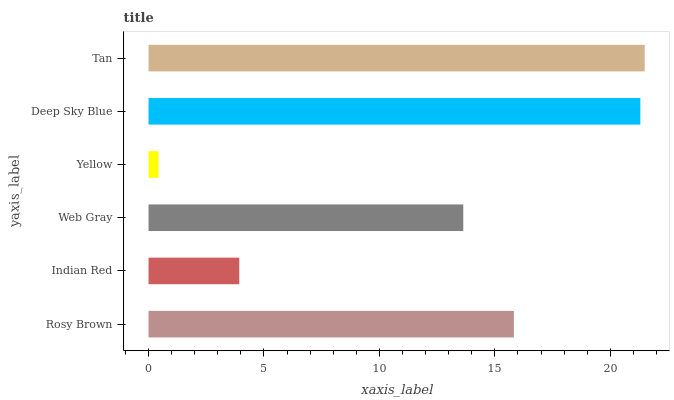Is Yellow the minimum?
Answer yes or no. Yes. Is Tan the maximum?
Answer yes or no. Yes. Is Indian Red the minimum?
Answer yes or no. No. Is Indian Red the maximum?
Answer yes or no. No. Is Rosy Brown greater than Indian Red?
Answer yes or no. Yes. Is Indian Red less than Rosy Brown?
Answer yes or no. Yes. Is Indian Red greater than Rosy Brown?
Answer yes or no. No. Is Rosy Brown less than Indian Red?
Answer yes or no. No. Is Rosy Brown the high median?
Answer yes or no. Yes. Is Web Gray the low median?
Answer yes or no. Yes. Is Tan the high median?
Answer yes or no. No. Is Indian Red the low median?
Answer yes or no. No. 